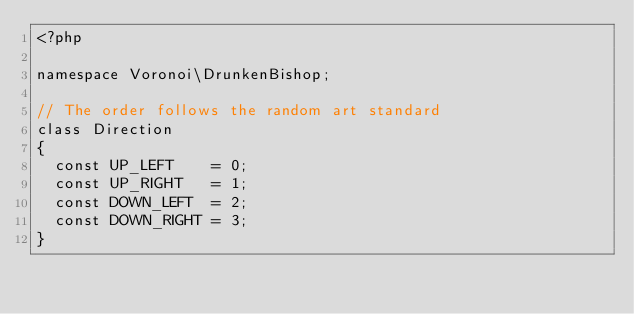Convert code to text. <code><loc_0><loc_0><loc_500><loc_500><_PHP_><?php

namespace Voronoi\DrunkenBishop;

// The order follows the random art standard
class Direction
{
  const UP_LEFT    = 0;
  const UP_RIGHT   = 1;
  const DOWN_LEFT  = 2;
  const DOWN_RIGHT = 3;
}
</code> 